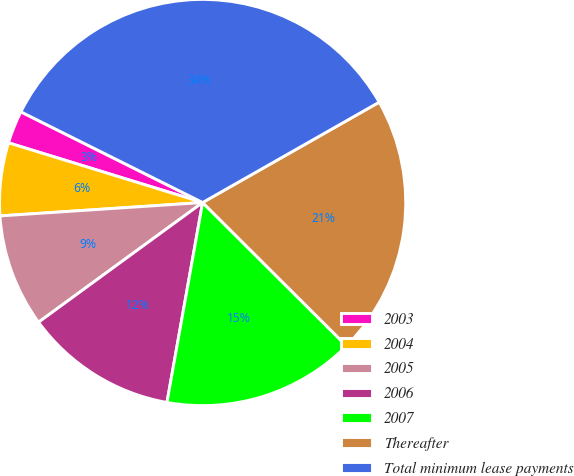Convert chart to OTSL. <chart><loc_0><loc_0><loc_500><loc_500><pie_chart><fcel>2003<fcel>2004<fcel>2005<fcel>2006<fcel>2007<fcel>Thereafter<fcel>Total minimum lease payments<nl><fcel>2.62%<fcel>5.8%<fcel>8.98%<fcel>12.16%<fcel>15.34%<fcel>20.7%<fcel>34.41%<nl></chart> 